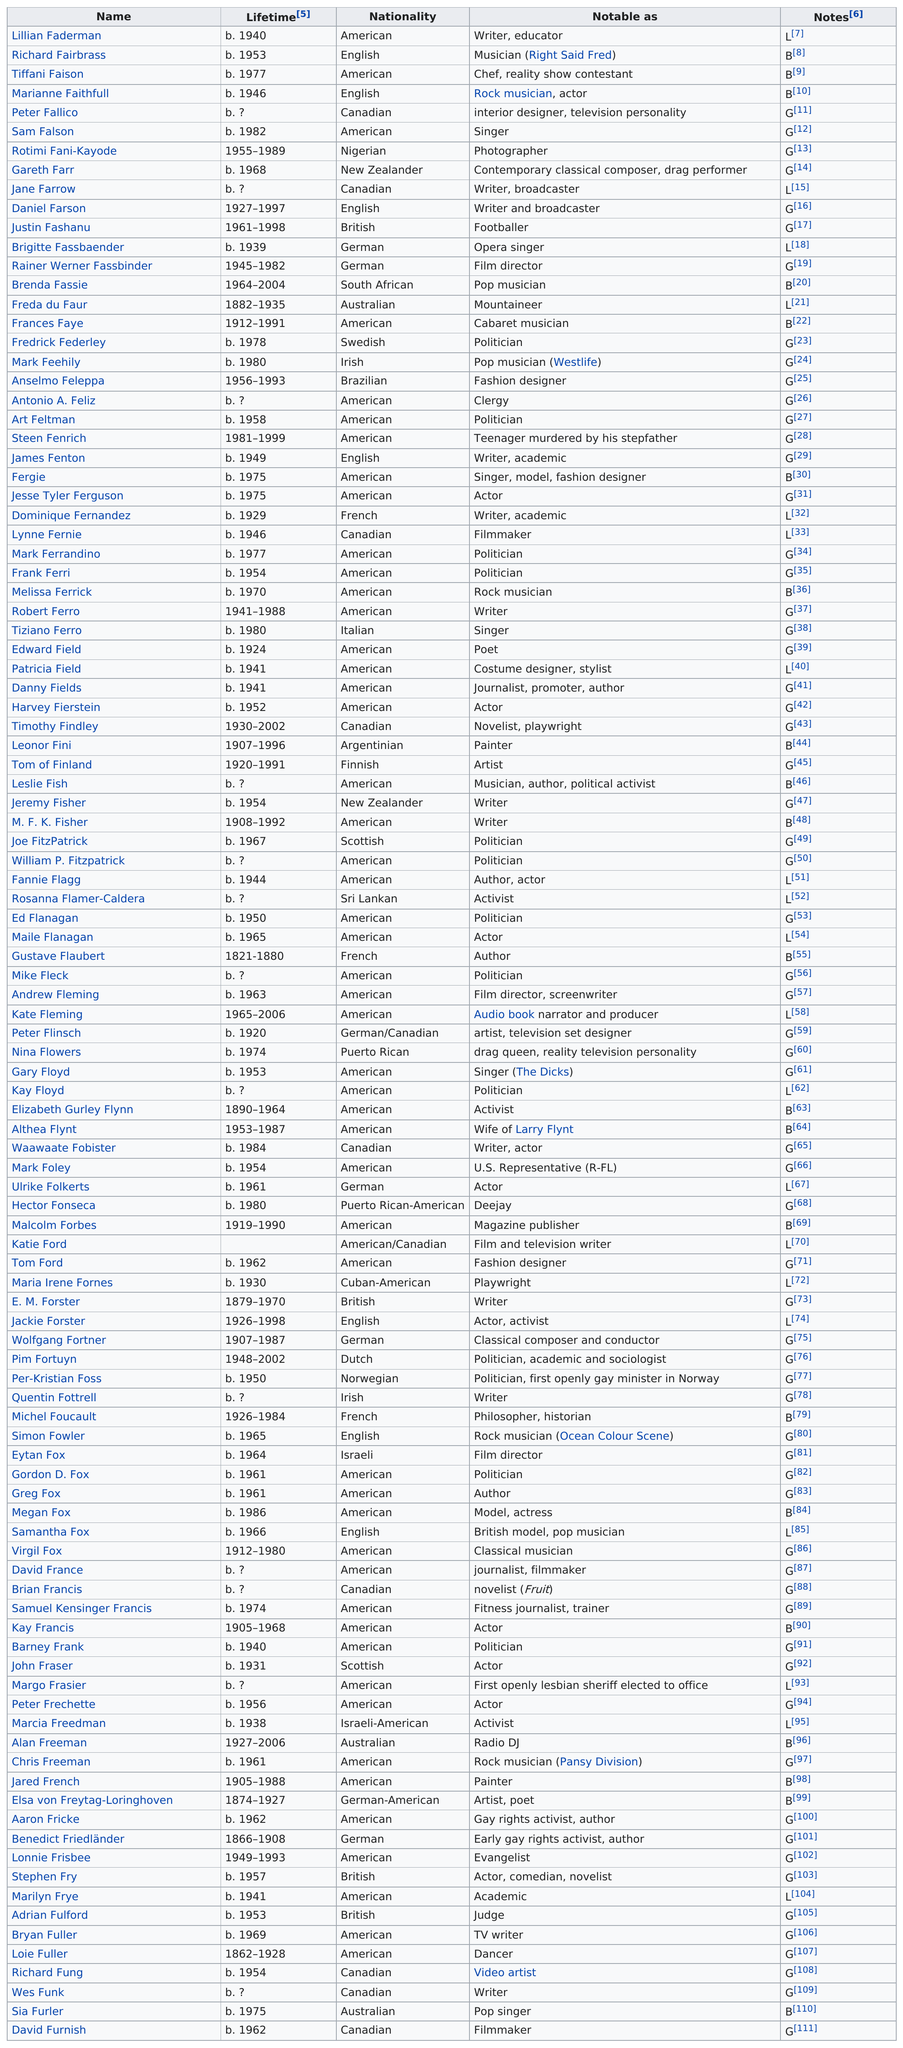Point out several critical features in this image. The name at the top of the list is Lillian Faderman. Brenda Fassie is the first pop musician on this list. Jesse Tyler Ferguson is followed by Dominique Fernandez in a list. Peter Fallico's name is preceded by Sam Falson's name. There are a total of 13 bisexual females in the table. 